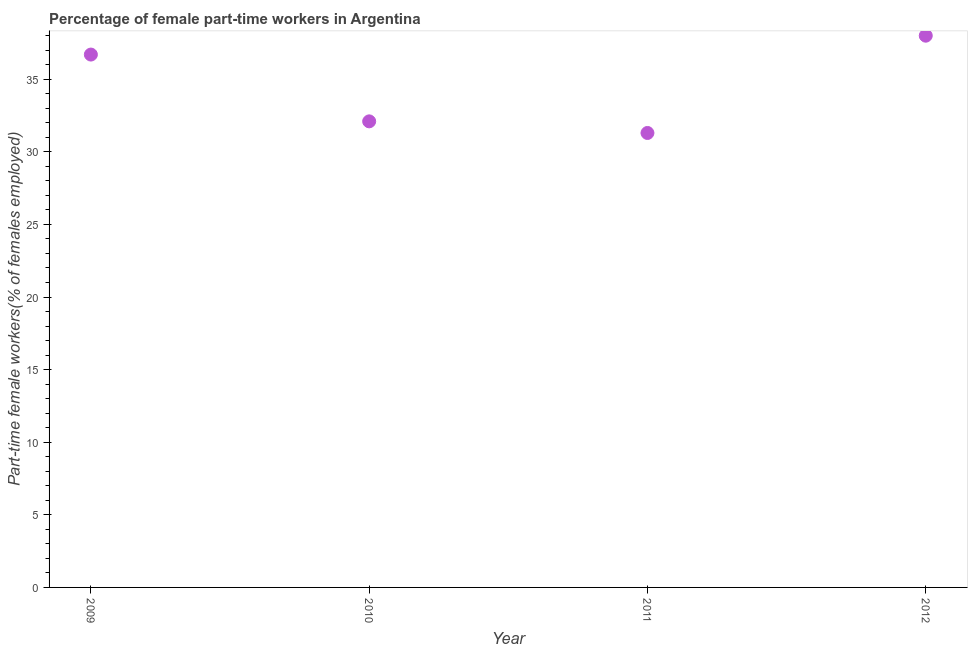What is the percentage of part-time female workers in 2011?
Your answer should be very brief. 31.3. Across all years, what is the minimum percentage of part-time female workers?
Make the answer very short. 31.3. What is the sum of the percentage of part-time female workers?
Make the answer very short. 138.1. What is the difference between the percentage of part-time female workers in 2009 and 2011?
Your answer should be very brief. 5.4. What is the average percentage of part-time female workers per year?
Provide a short and direct response. 34.52. What is the median percentage of part-time female workers?
Keep it short and to the point. 34.4. Do a majority of the years between 2010 and 2012 (inclusive) have percentage of part-time female workers greater than 1 %?
Give a very brief answer. Yes. What is the ratio of the percentage of part-time female workers in 2009 to that in 2012?
Your answer should be compact. 0.97. Is the difference between the percentage of part-time female workers in 2010 and 2012 greater than the difference between any two years?
Your answer should be very brief. No. What is the difference between the highest and the second highest percentage of part-time female workers?
Provide a short and direct response. 1.3. What is the difference between the highest and the lowest percentage of part-time female workers?
Provide a succinct answer. 6.7. In how many years, is the percentage of part-time female workers greater than the average percentage of part-time female workers taken over all years?
Offer a terse response. 2. Does the percentage of part-time female workers monotonically increase over the years?
Make the answer very short. No. How many years are there in the graph?
Keep it short and to the point. 4. Are the values on the major ticks of Y-axis written in scientific E-notation?
Make the answer very short. No. Does the graph contain any zero values?
Your response must be concise. No. Does the graph contain grids?
Your answer should be very brief. No. What is the title of the graph?
Keep it short and to the point. Percentage of female part-time workers in Argentina. What is the label or title of the Y-axis?
Offer a very short reply. Part-time female workers(% of females employed). What is the Part-time female workers(% of females employed) in 2009?
Ensure brevity in your answer.  36.7. What is the Part-time female workers(% of females employed) in 2010?
Provide a succinct answer. 32.1. What is the Part-time female workers(% of females employed) in 2011?
Your answer should be compact. 31.3. What is the Part-time female workers(% of females employed) in 2012?
Your response must be concise. 38. What is the difference between the Part-time female workers(% of females employed) in 2010 and 2011?
Offer a terse response. 0.8. What is the ratio of the Part-time female workers(% of females employed) in 2009 to that in 2010?
Keep it short and to the point. 1.14. What is the ratio of the Part-time female workers(% of females employed) in 2009 to that in 2011?
Your answer should be very brief. 1.17. What is the ratio of the Part-time female workers(% of females employed) in 2010 to that in 2012?
Your response must be concise. 0.84. What is the ratio of the Part-time female workers(% of females employed) in 2011 to that in 2012?
Your answer should be compact. 0.82. 